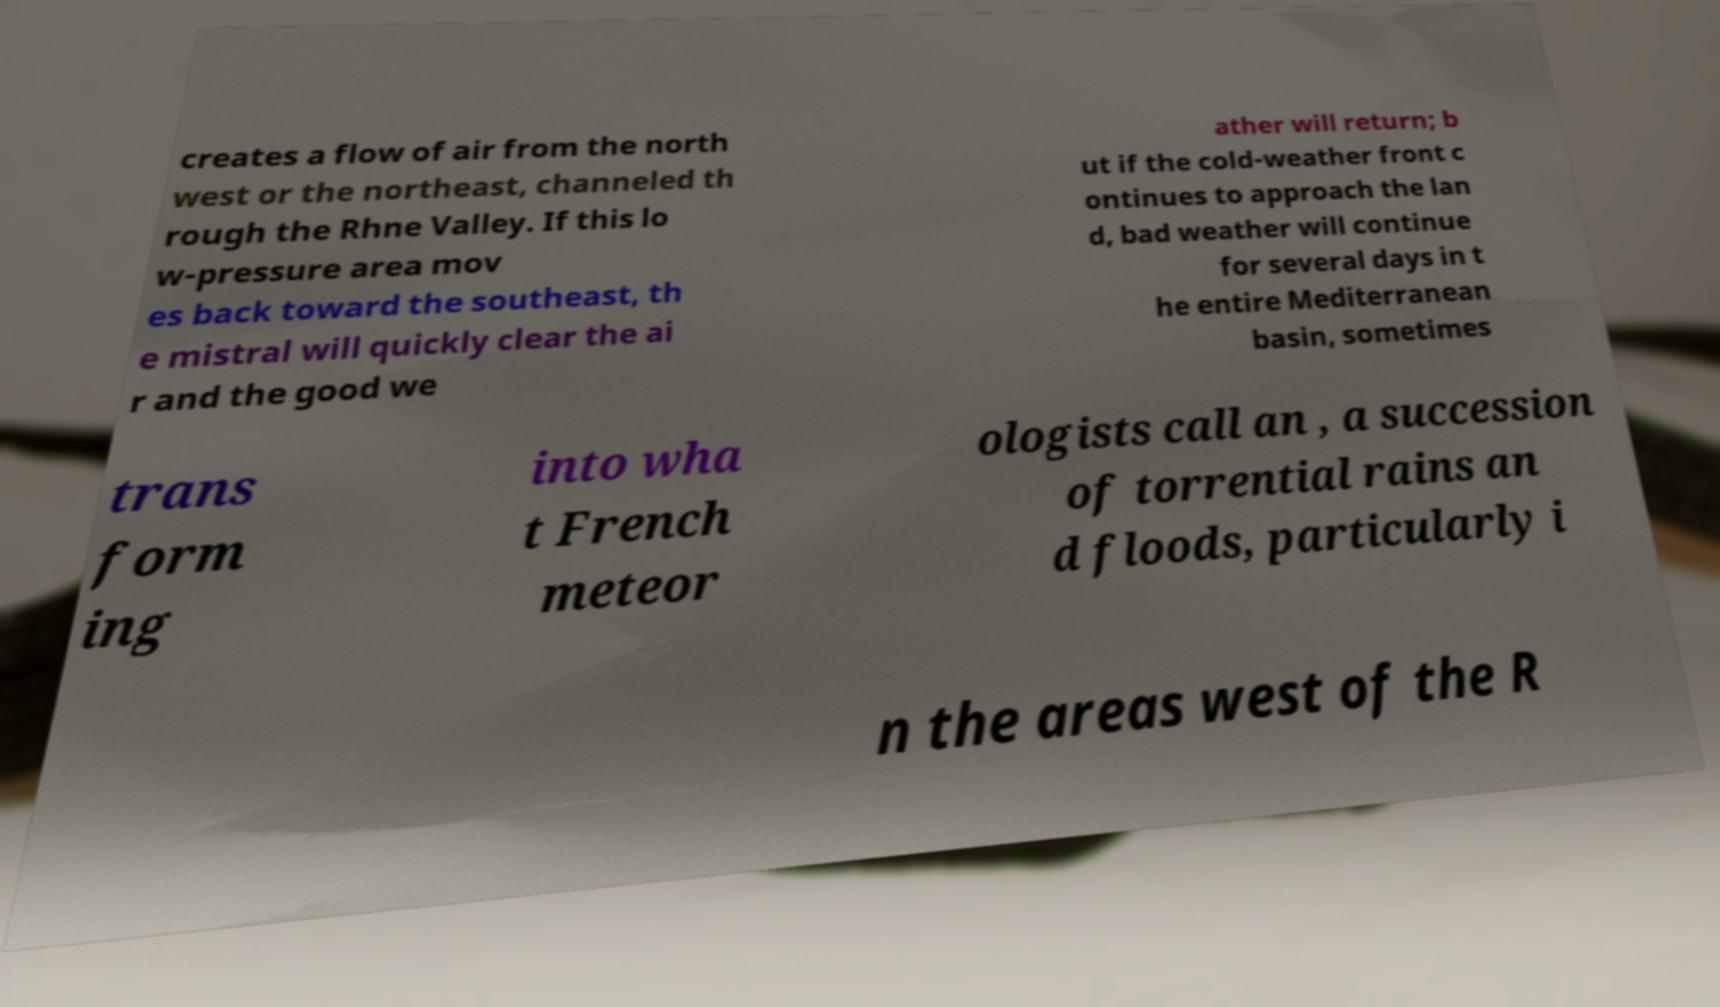Please identify and transcribe the text found in this image. creates a flow of air from the north west or the northeast, channeled th rough the Rhne Valley. If this lo w-pressure area mov es back toward the southeast, th e mistral will quickly clear the ai r and the good we ather will return; b ut if the cold-weather front c ontinues to approach the lan d, bad weather will continue for several days in t he entire Mediterranean basin, sometimes trans form ing into wha t French meteor ologists call an , a succession of torrential rains an d floods, particularly i n the areas west of the R 